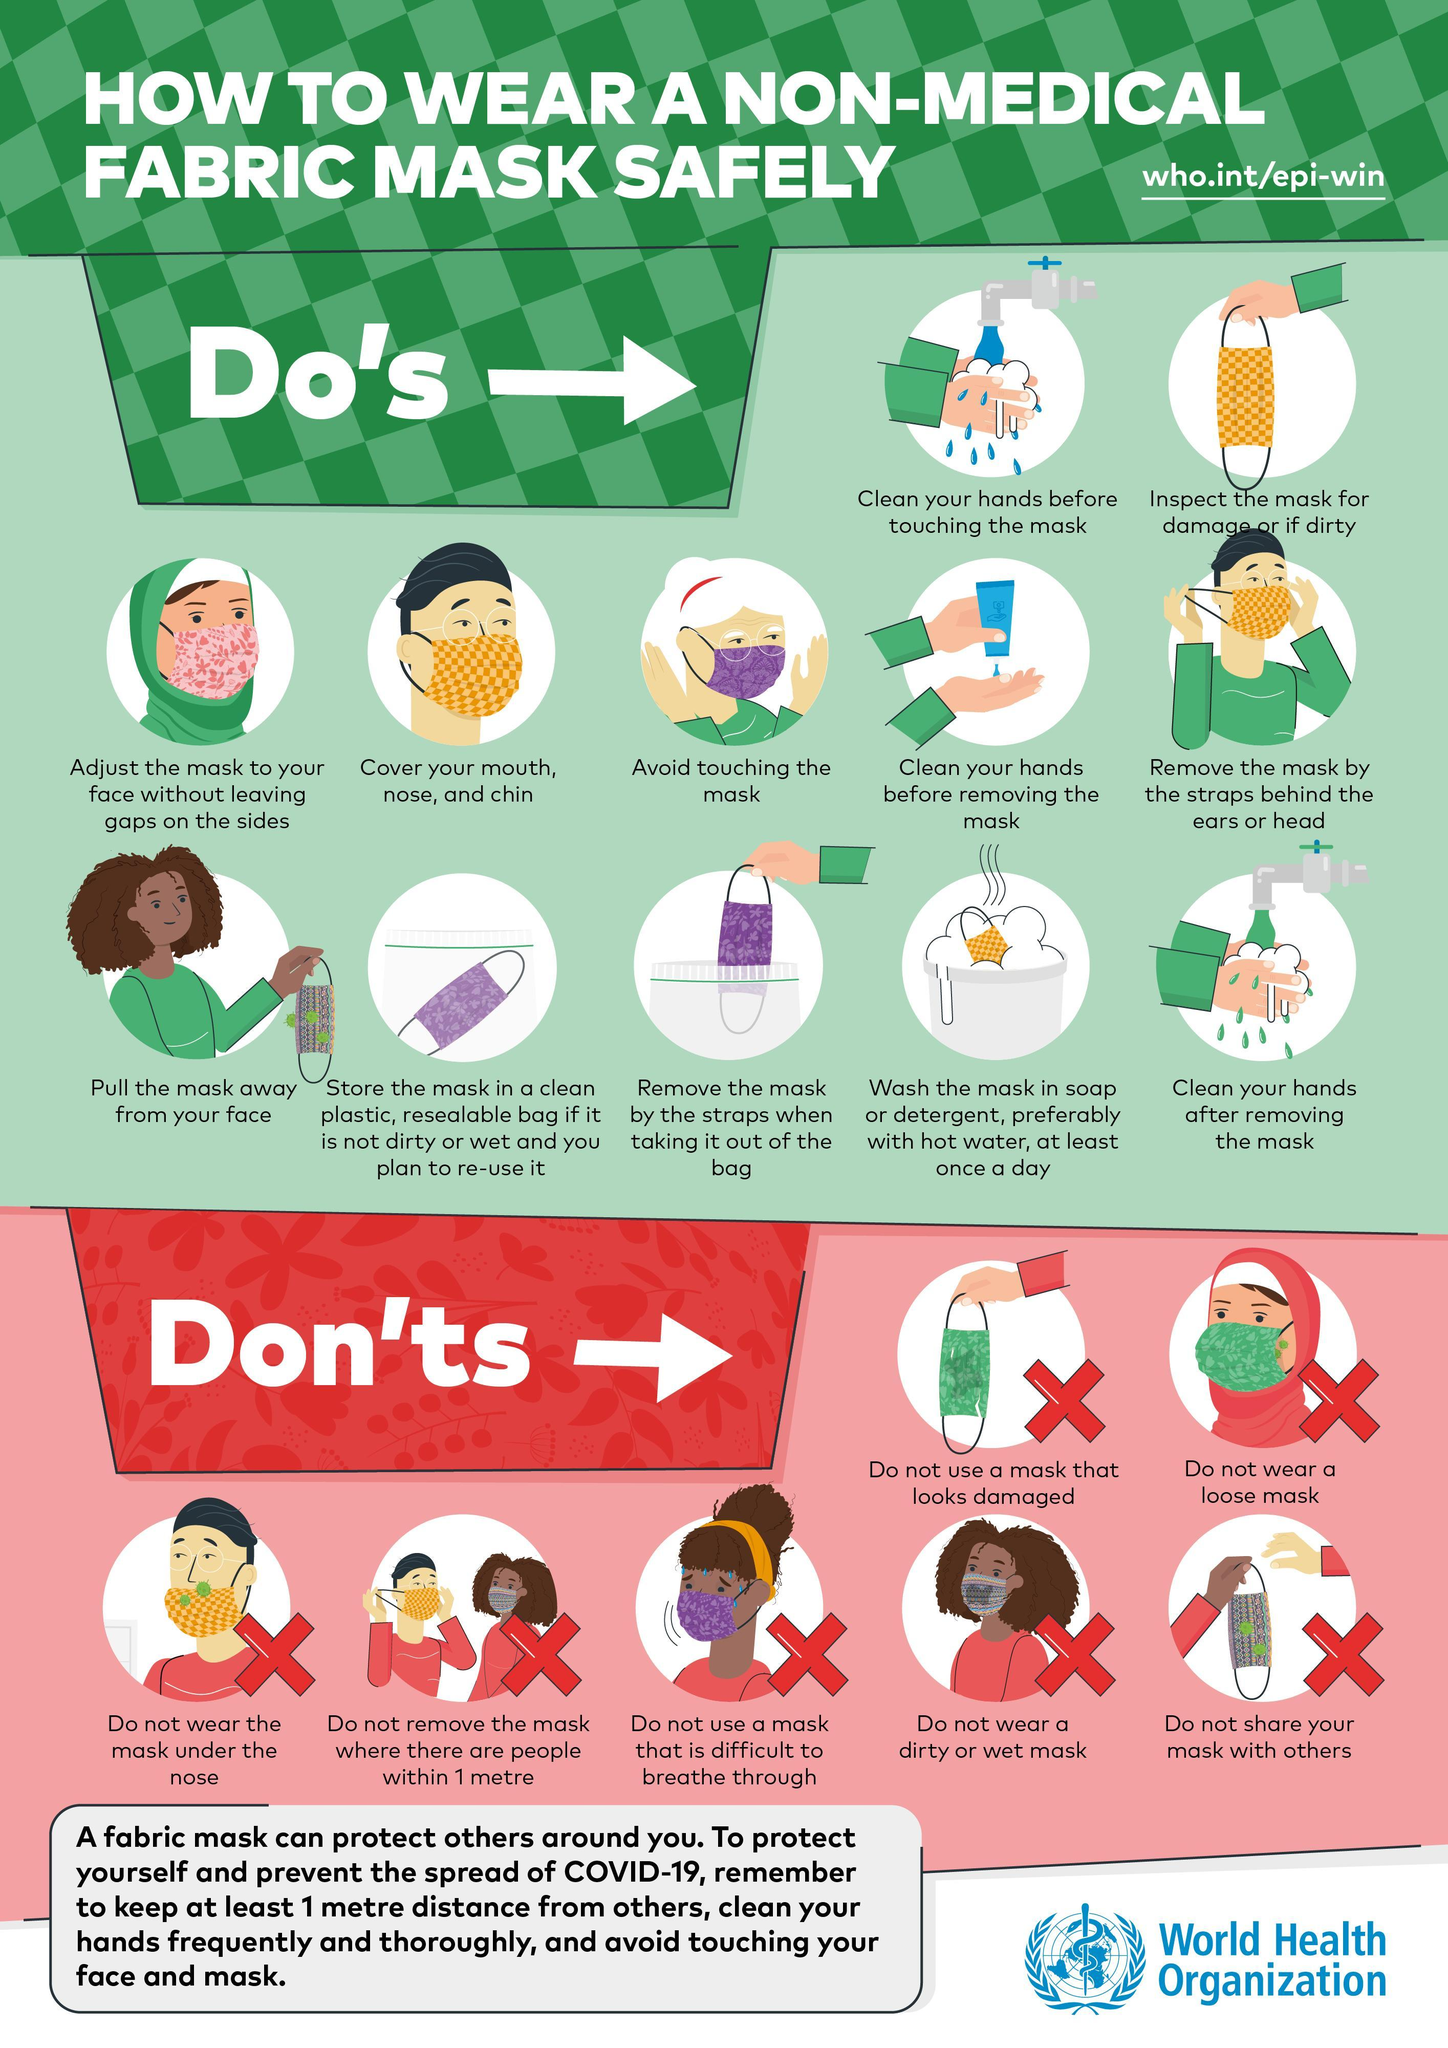What is the background color given to all Don'ts- yellow, green, red, black?
Answer the question with a short phrase. red What kind of a mask you shouldn't wear? loose mask What you should avoid while wearing the mask? Avoid touching the mask What is advised to do after removing the mask? Clean your hands after removing the mask What is the background color given to all Do's- red, green, yellow, orange? green Why you need to thoroughly check the mask before wearing? for damage or if dirty 